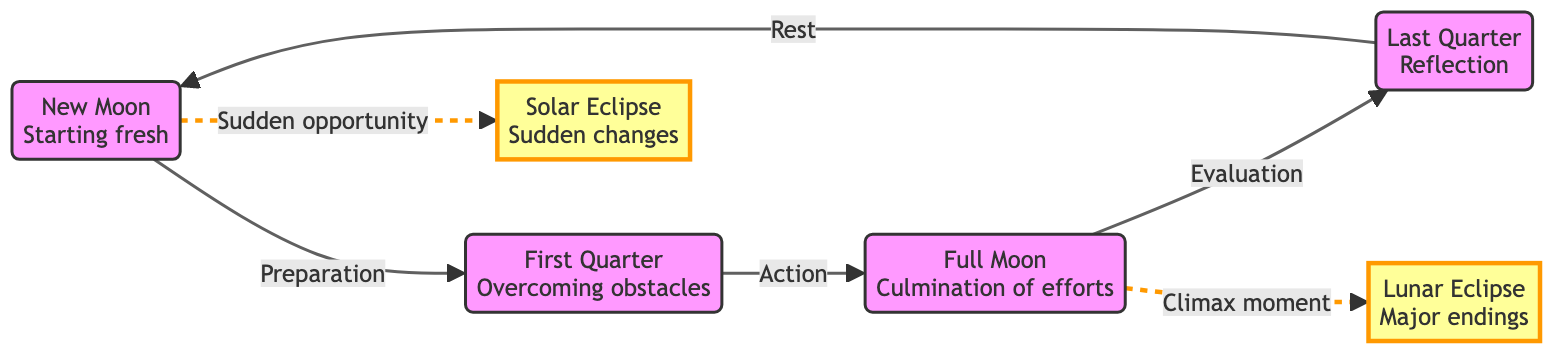What is the first phase after the New Moon? The diagram shows that the New Moon leads to the First Quarter phase, indicating that the First Quarter is the next phase following the New Moon.
Answer: First Quarter How many major eclipse events are represented in the diagram? The diagram includes two eclipse events: a Solar Eclipse and a Lunar Eclipse, hence the total count of major eclipse events is two.
Answer: 2 What does the Full Moon signify in this diagram? According to the diagram, the Full Moon signifies the culmination of efforts, which is a critical milestone in the custody battle context.
Answer: Culmination of efforts Which phase comes after the Last Quarter? The diagram indicates that the Last Quarter is followed by the New Moon, completing the cycle of lunar phases.
Answer: New Moon What is the relationship between the Full Moon and the Lunar Eclipse? The diagram illustrates a dashed line connecting the Full Moon to the Lunar Eclipse, indicating that the Full Moon is associated with a climax moment during a Lunar Eclipse.
Answer: Climax moment What type of change is symbolized by the Solar Eclipse? The Solar Eclipse is labeled in the diagram as representing sudden changes, indicating a significant shift or opportunity in the context of the custody battle.
Answer: Sudden changes How many phases are described in the diagram? The diagram describes a total of five phases (New Moon, First Quarter, Full Moon, Last Quarter) each representing different stages of the custody battle process.
Answer: 5 What does the Last Quarter signify, according to the diagram? In the diagram, the Last Quarter is described as a time for reflection, indicating a period of evaluation and contemplation in the custody battle journey.
Answer: Reflection How are obstacles addressed in the diagram? The diagram shows that overcoming obstacles is a key element during the First Quarter phase, emphasizing the importance of this phase in navigating challenges in the custody battle.
Answer: Overcoming obstacles 